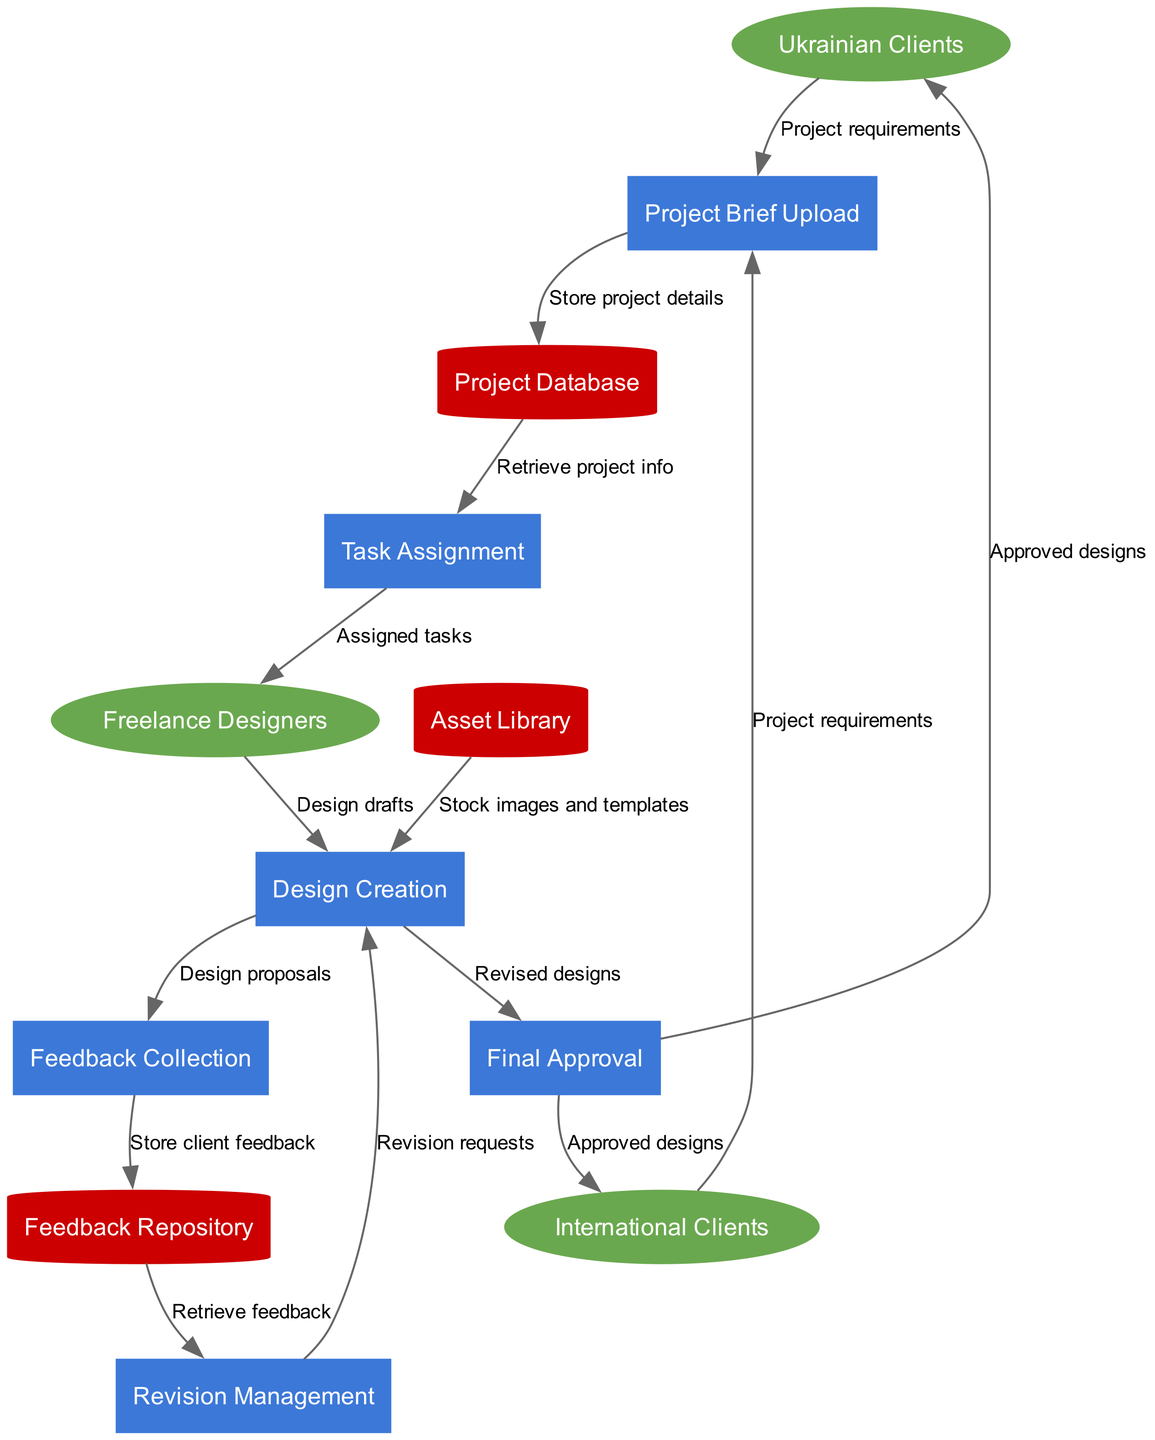What are the external entities in the diagram? The three external entities are "Ukrainian Clients", "International Clients", and "Freelance Designers". They are represented as ellipse-shaped nodes at the top of the diagram.
Answer: Ukrainian Clients, International Clients, Freelance Designers How many processes are shown in the diagram? The diagram contains six processes: "Project Brief Upload", "Task Assignment", "Design Creation", "Feedback Collection", "Revision Management", and "Final Approval". Each process is represented in a differently colored rectangle.
Answer: 6 What data store receives feedback? The "Feedback Repository" receives feedback after it is collected from clients. This is indicated by the specific data flow labeled "Store client feedback" that connects "Feedback Collection" to "Feedback Repository".
Answer: Feedback Repository Which external entity submits project requirements to "Project Brief Upload"? Both "Ukrainian Clients" and "International Clients" submit project requirements to the "Project Brief Upload" process. This is shown through two distinct data flows leading towards the "Project Brief Upload".
Answer: Ukrainian Clients, International Clients What is the data flow from "Design Creation" to "Final Approval"? The data flow from "Design Creation" to "Final Approval" is labeled as "Revised designs". This indicates that after designs are revised, they are sent for final approval.
Answer: Revised designs Which process follows "Feedback Collection"? The process that follows "Feedback Collection" is "Revision Management". The flow of data is indicated by the information moving from "Feedback Collection" to "Revision Management".
Answer: Revision Management How many different types of nodes are in the diagram? There are three types of nodes in the diagram: external entities (ellipse), processes (rectangle), and data stores (cylinder). Each type is clearly represented by different shapes.
Answer: 3 What is the purpose of the "Asset Library" data store in the design workflow? The "Asset Library" provides "Stock images and templates" to the "Design Creation" process. This relationship is shown by the data flow connecting these two nodes.
Answer: Stock images and templates How is feedback stored after collection? Feedback is stored in the "Feedback Repository" after it has been collected from clients. This is indicated by the arrow labeled "Store client feedback" leading from "Feedback Collection" to "Feedback Repository".
Answer: Feedback Repository 